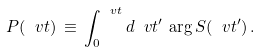Convert formula to latex. <formula><loc_0><loc_0><loc_500><loc_500>P ( \ v t ) \, \equiv \, \int _ { 0 } ^ { \ v t } d \ v t ^ { \prime } \, \arg S ( \ v t ^ { \prime } ) \, .</formula> 